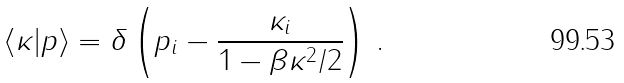Convert formula to latex. <formula><loc_0><loc_0><loc_500><loc_500>\langle \kappa | p \rangle = \delta \left ( p _ { i } - \frac { \kappa _ { i } } { 1 - \beta \kappa ^ { 2 } / 2 } \right ) \, .</formula> 